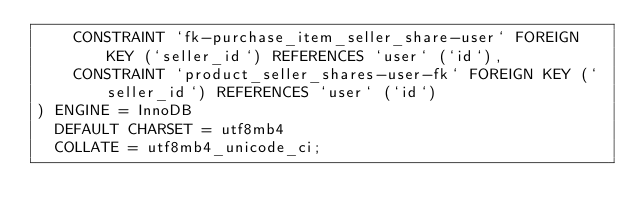<code> <loc_0><loc_0><loc_500><loc_500><_SQL_>    CONSTRAINT `fk-purchase_item_seller_share-user` FOREIGN KEY (`seller_id`) REFERENCES `user` (`id`),
    CONSTRAINT `product_seller_shares-user-fk` FOREIGN KEY (`seller_id`) REFERENCES `user` (`id`)
) ENGINE = InnoDB
  DEFAULT CHARSET = utf8mb4
  COLLATE = utf8mb4_unicode_ci;
</code> 